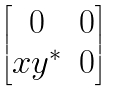Convert formula to latex. <formula><loc_0><loc_0><loc_500><loc_500>\begin{bmatrix} 0 & 0 \\ x y ^ { * } & 0 \end{bmatrix}</formula> 